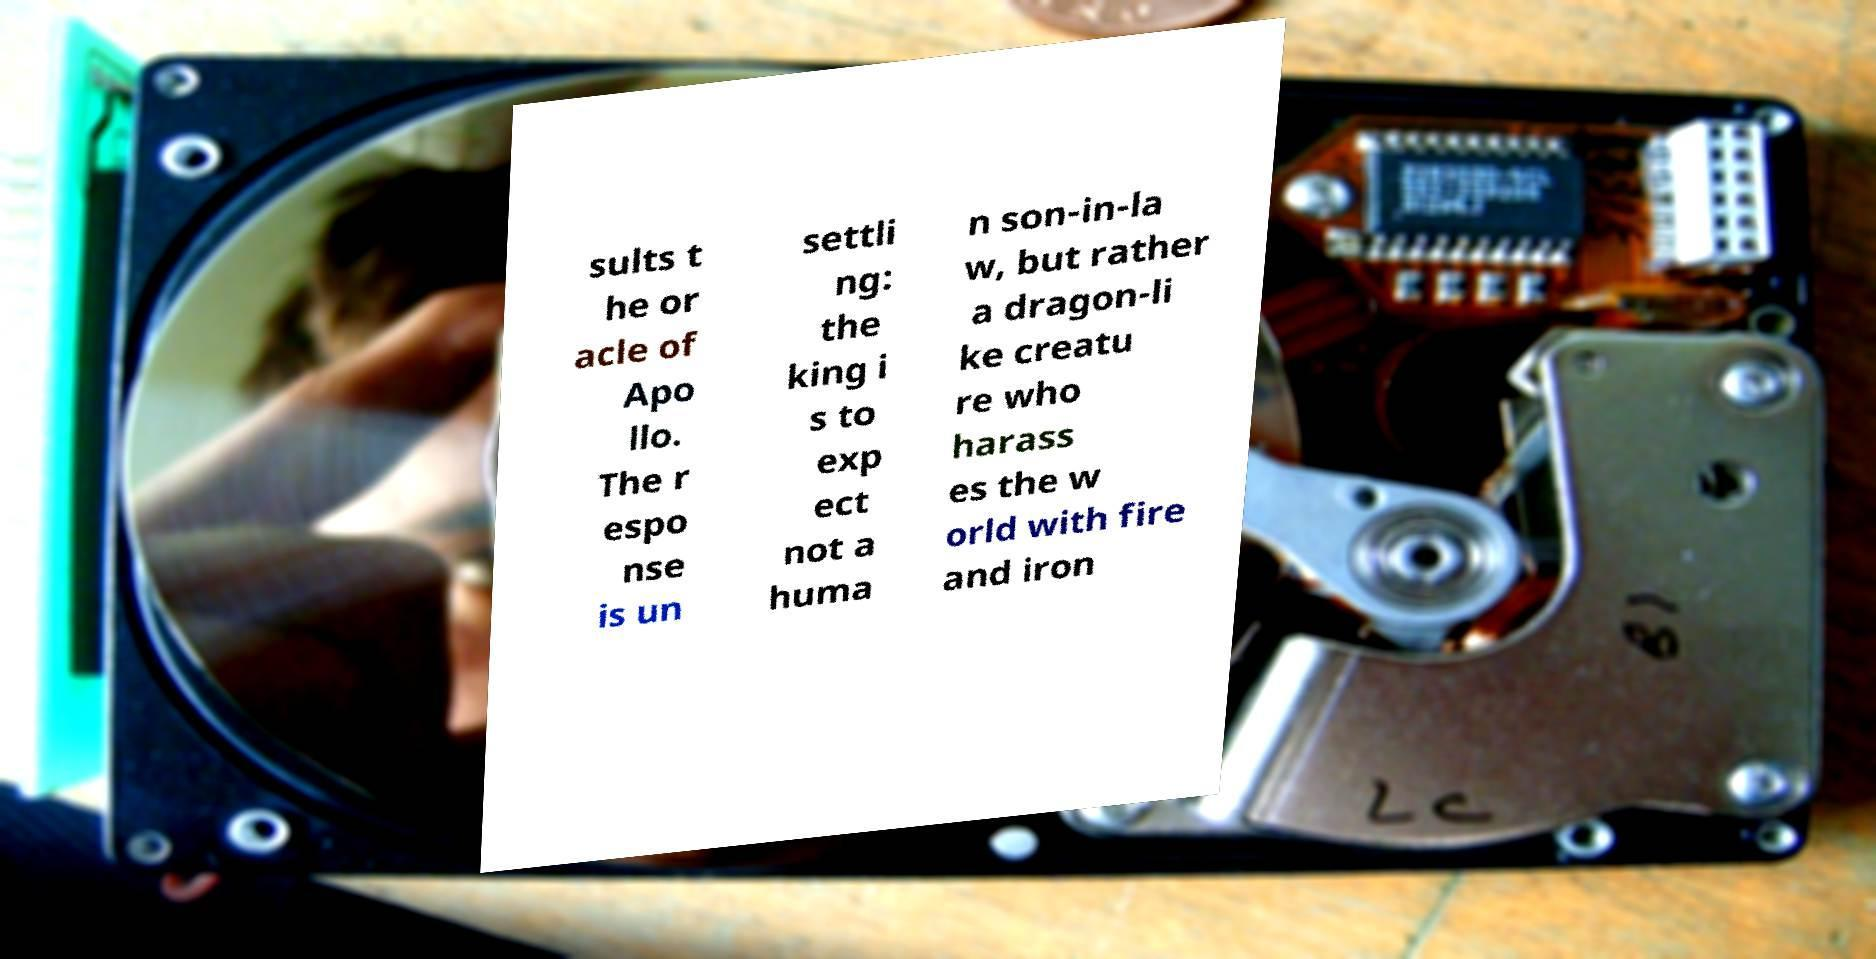What messages or text are displayed in this image? I need them in a readable, typed format. sults t he or acle of Apo llo. The r espo nse is un settli ng: the king i s to exp ect not a huma n son-in-la w, but rather a dragon-li ke creatu re who harass es the w orld with fire and iron 